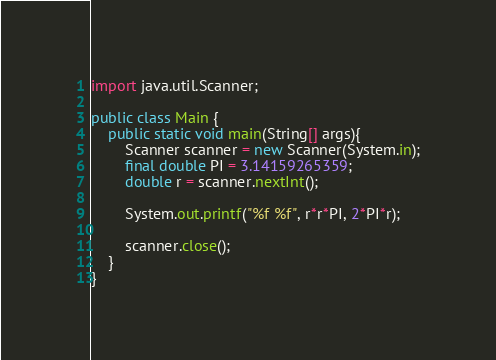Convert code to text. <code><loc_0><loc_0><loc_500><loc_500><_Java_>import java.util.Scanner;

public class Main {
    public static void main(String[] args){
        Scanner scanner = new Scanner(System.in);
        final double PI = 3.14159265359;
        double r = scanner.nextInt();

        System.out.printf("%f %f", r*r*PI, 2*PI*r);

        scanner.close();
    }
}
</code> 